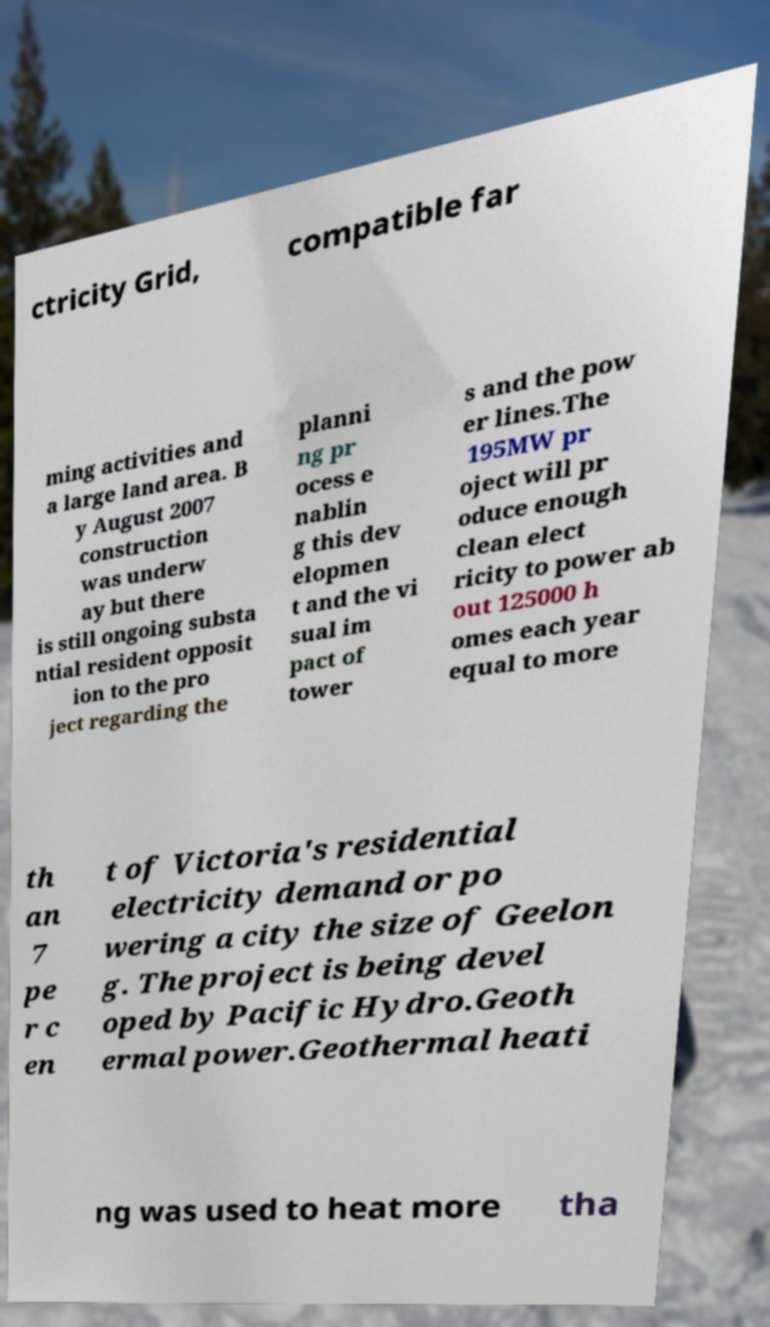Can you accurately transcribe the text from the provided image for me? ctricity Grid, compatible far ming activities and a large land area. B y August 2007 construction was underw ay but there is still ongoing substa ntial resident opposit ion to the pro ject regarding the planni ng pr ocess e nablin g this dev elopmen t and the vi sual im pact of tower s and the pow er lines.The 195MW pr oject will pr oduce enough clean elect ricity to power ab out 125000 h omes each year equal to more th an 7 pe r c en t of Victoria's residential electricity demand or po wering a city the size of Geelon g. The project is being devel oped by Pacific Hydro.Geoth ermal power.Geothermal heati ng was used to heat more tha 